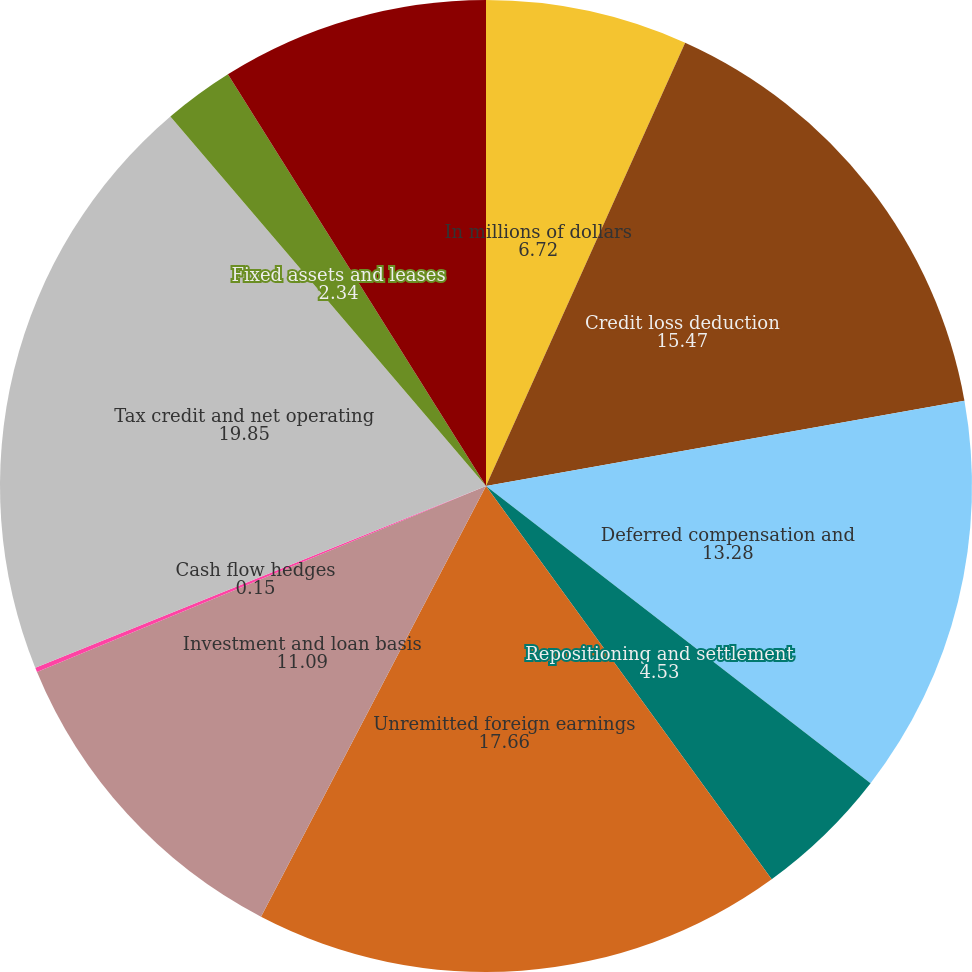<chart> <loc_0><loc_0><loc_500><loc_500><pie_chart><fcel>In millions of dollars<fcel>Credit loss deduction<fcel>Deferred compensation and<fcel>Repositioning and settlement<fcel>Unremitted foreign earnings<fcel>Investment and loan basis<fcel>Cash flow hedges<fcel>Tax credit and net operating<fcel>Fixed assets and leases<fcel>Other deferred tax assets<nl><fcel>6.72%<fcel>15.47%<fcel>13.28%<fcel>4.53%<fcel>17.66%<fcel>11.09%<fcel>0.15%<fcel>19.85%<fcel>2.34%<fcel>8.91%<nl></chart> 